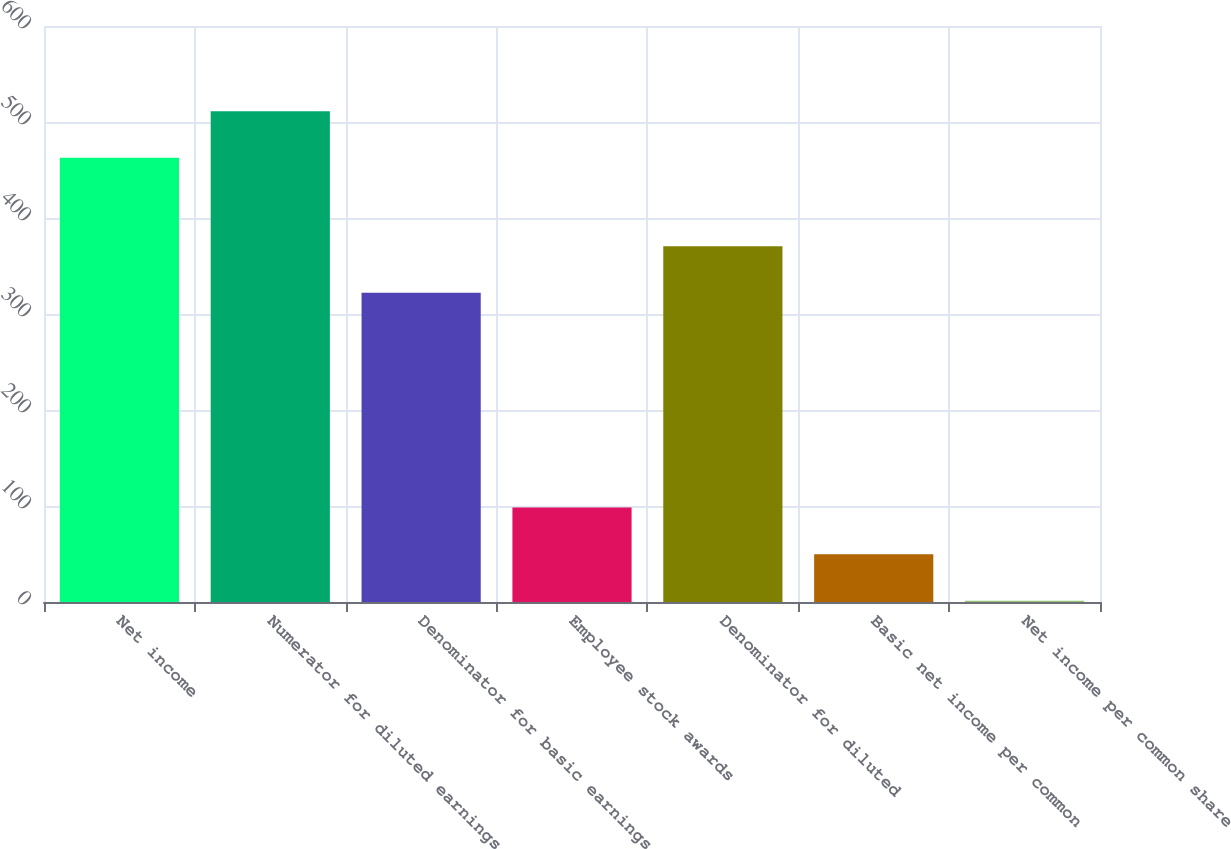Convert chart to OTSL. <chart><loc_0><loc_0><loc_500><loc_500><bar_chart><fcel>Net income<fcel>Numerator for diluted earnings<fcel>Denominator for basic earnings<fcel>Employee stock awards<fcel>Denominator for diluted<fcel>Basic net income per common<fcel>Net income per common share<nl><fcel>462.7<fcel>511.23<fcel>322.1<fcel>98.39<fcel>370.63<fcel>49.86<fcel>1.33<nl></chart> 